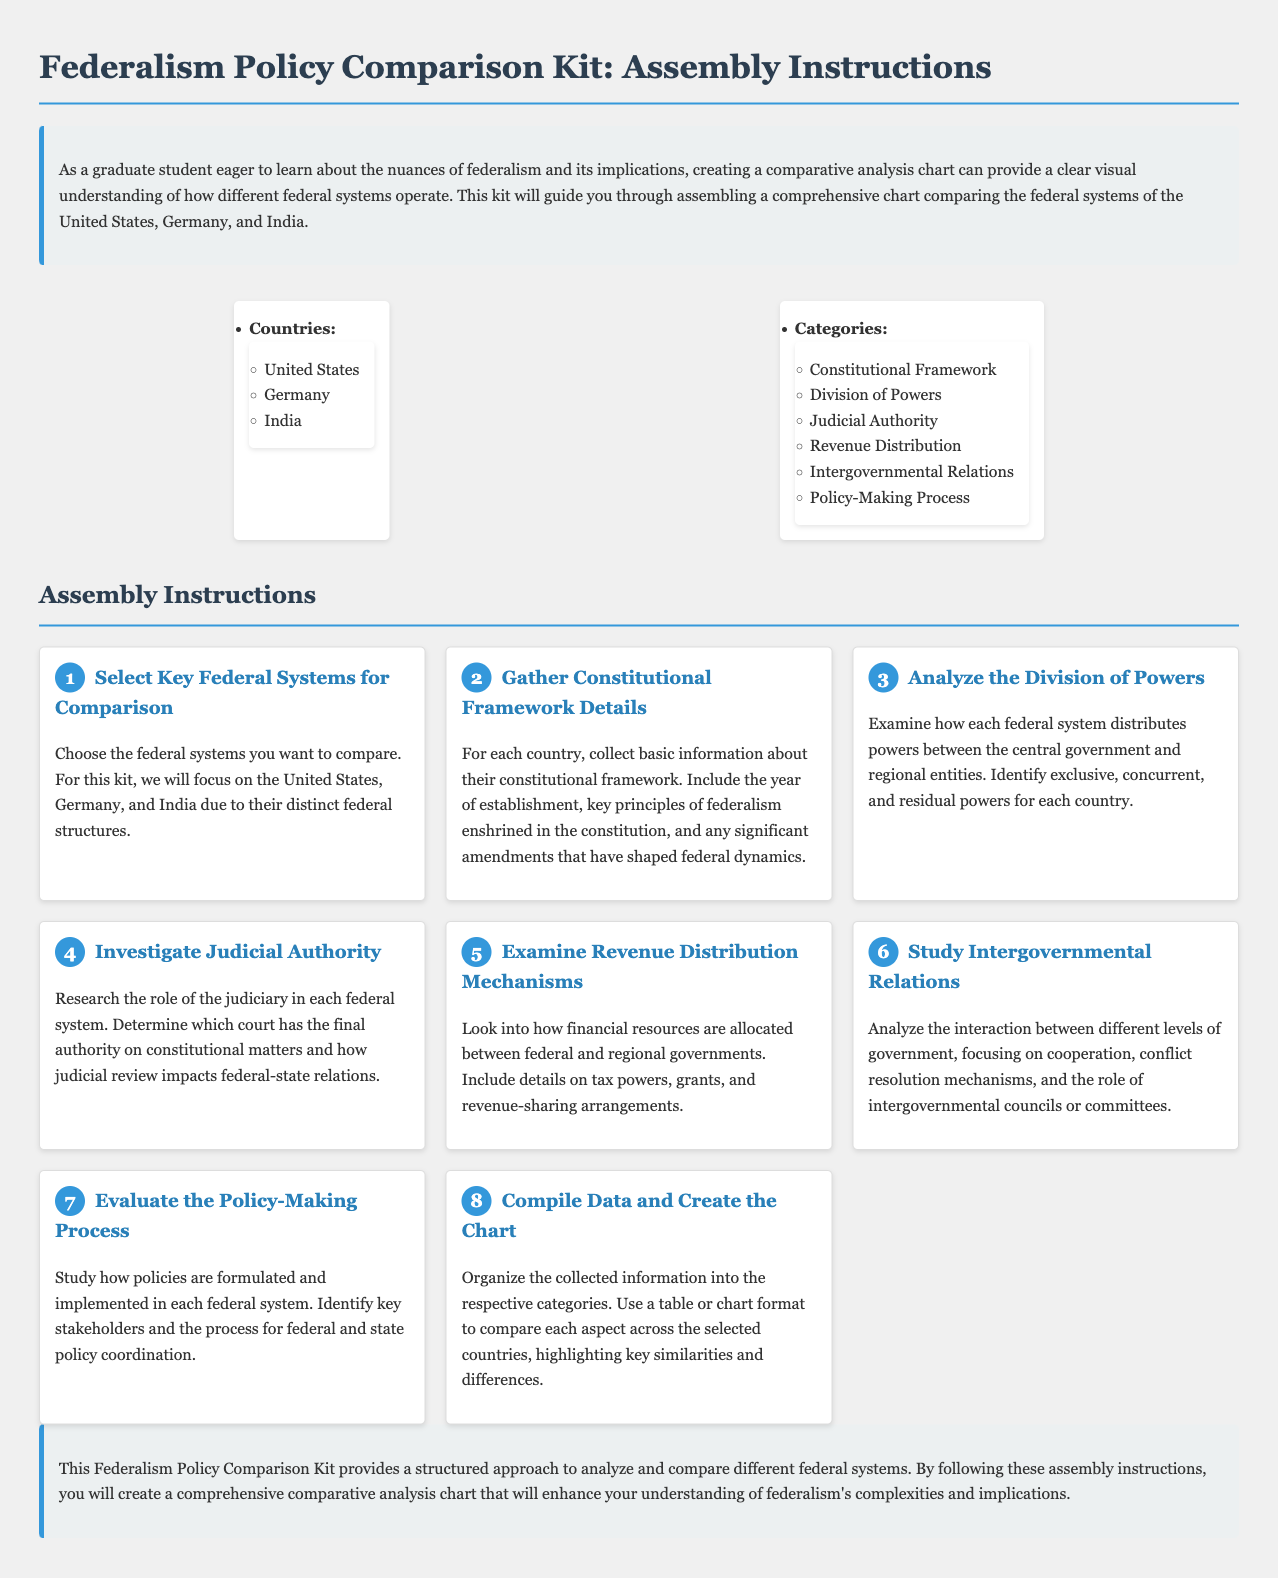What are the three countries compared in the kit? The kit focuses on comparing the federal systems of the United States, Germany, and India.
Answer: United States, Germany, India How many categories are included in the comparative analysis? The document lists six categories for comparison under the federal systems.
Answer: Six What is the first step in the assembly instructions? The first step entails selecting key federal systems for comparison, focusing on specific countries.
Answer: Select Key Federal Systems for Comparison Which category examines how powers are divided? This category concerns the examination of power distribution between the central and regional governments.
Answer: Division of Powers What is the final authority on constitutional matters? The document prompts research on the judiciary's role, specifically identifying which court holds final authority.
Answer: Judiciary Which step involves evaluating the policy-making process? This step addresses how policies are developed and executed in each federal system, identifying key stakeholders and coordination processes.
Answer: Evaluate the Policy-Making Process What year of establishment is required during the data collection? When gathering information, the collection should include the year of establishment of each country's constitutional framework.
Answer: Year of establishment What should the data be organized into? The collected information should be organized into respective categories for comparison across the selected federal systems.
Answer: Categories 